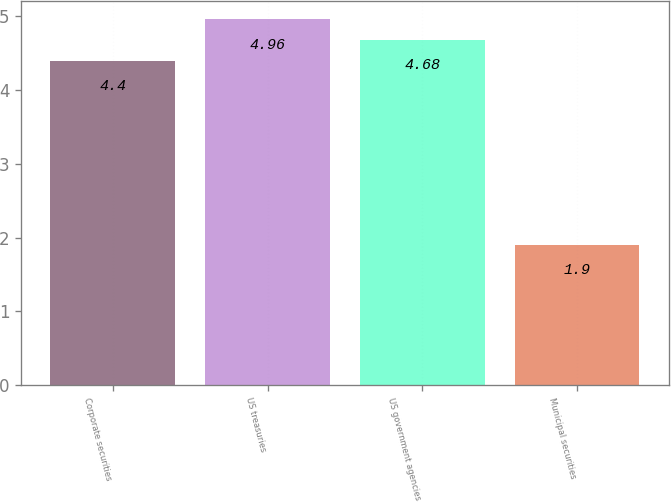Convert chart. <chart><loc_0><loc_0><loc_500><loc_500><bar_chart><fcel>Corporate securities<fcel>US treasuries<fcel>US government agencies<fcel>Municipal securities<nl><fcel>4.4<fcel>4.96<fcel>4.68<fcel>1.9<nl></chart> 